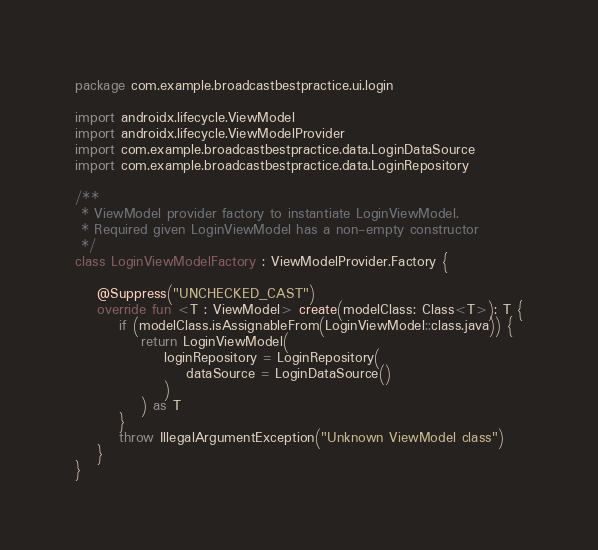<code> <loc_0><loc_0><loc_500><loc_500><_Kotlin_>package com.example.broadcastbestpractice.ui.login

import androidx.lifecycle.ViewModel
import androidx.lifecycle.ViewModelProvider
import com.example.broadcastbestpractice.data.LoginDataSource
import com.example.broadcastbestpractice.data.LoginRepository

/**
 * ViewModel provider factory to instantiate LoginViewModel.
 * Required given LoginViewModel has a non-empty constructor
 */
class LoginViewModelFactory : ViewModelProvider.Factory {

    @Suppress("UNCHECKED_CAST")
    override fun <T : ViewModel> create(modelClass: Class<T>): T {
        if (modelClass.isAssignableFrom(LoginViewModel::class.java)) {
            return LoginViewModel(
                loginRepository = LoginRepository(
                    dataSource = LoginDataSource()
                )
            ) as T
        }
        throw IllegalArgumentException("Unknown ViewModel class")
    }
}</code> 